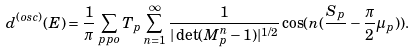<formula> <loc_0><loc_0><loc_500><loc_500>d ^ { ( o s c ) } ( E ) = \frac { 1 } { \pi } \sum _ { p p o } T _ { p } \sum _ { n = 1 } ^ { \infty } \frac { 1 } { | \det ( M _ { p } ^ { n } - 1 ) | ^ { 1 / 2 } } \cos ( n ( \frac { S _ { p } } { } - \frac { \pi } { 2 } \mu _ { p } ) ) .</formula> 